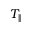<formula> <loc_0><loc_0><loc_500><loc_500>T _ { \| }</formula> 